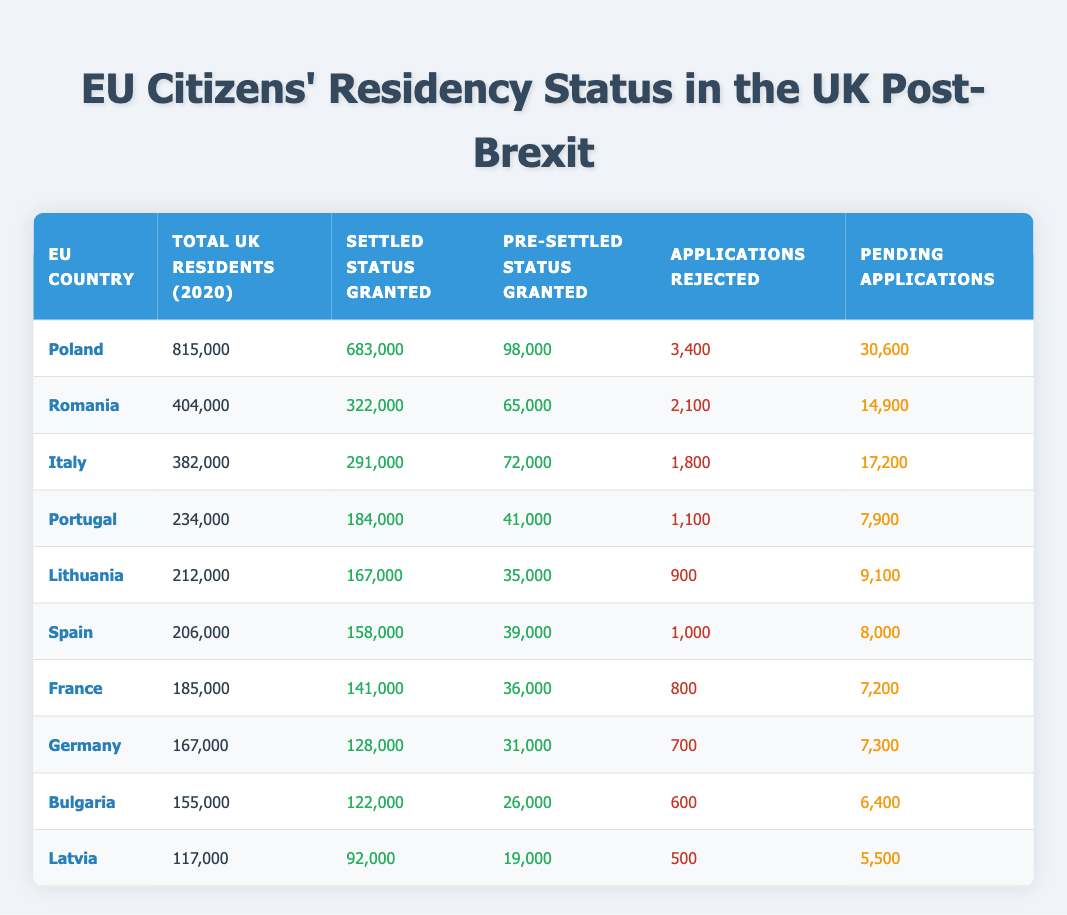What is the total number of applications rejected for EU citizens from Poland? The table shows that Poland had 3,400 applications rejected. It's taken directly from the "Applications Rejected" column for Poland.
Answer: 3,400 How many total applications (both granted statuses and applications rejected) were there for Romanian citizens? Combining the granted statuses (322,000 + 65,000) and rejected applications (2,100), the total applications can be calculated as 322,000 + 65,000 + 2,100 = 389,100.
Answer: 389,100 Is the number of EU citizens in the UK from Italy greater than that from Spain? The total UK residents from Italy are 382,000, while from Spain, it's 206,000. Since 382,000 is more than 206,000, the statement is true.
Answer: Yes What is the total number of settled and pre-settled statuses granted to EU citizens from Lithuania and Latvia combined? For Lithuania, the granted statuses total 167,000 (settled) + 35,000 (pre-settled) = 202,000. For Latvia, they total 92,000 (settled) + 19,000 (pre-settled) = 111,000. Adding both totals gives 202,000 + 111,000 = 313,000.
Answer: 313,000 Which EU country had the highest number of pending applications? Upon reviewing the table, Poland has the highest number of pending applications recorded at 30,600. This is taken from the "Pending Applications" column.
Answer: Poland What percentage of the total UK residents from Portugal have been granted settled status? The total UK residents from Portugal are 234,000. The number granted settled status is 184,000. To find the percentage, divide 184,000 by 234,000 and multiply by 100. This gives approximately 78.6%.
Answer: 78.6% Which country had more applications rejected: Lithuania or Bulgaria? Lithuania had 900 applications rejected while Bulgaria had 600 rejected. Since 900 is greater than 600, Lithuania had more rejected applications.
Answer: Lithuania How many more settled statuses were granted to EU citizens from Germany compared to Latvia? Germany had 128,000 settled statuses granted, while Latvia had 92,000. The difference is 128,000 - 92,000 = 36,000.
Answer: 36,000 What is the average number of applications pending across the listed EU countries? To find the average, sum all pending applications: 30,600 + 14,900 + 17,200 + 7,900 + 9,100 + 8,000 + 7,200 + 7,300 + 6,400 + 5,500 = 125,700. There are 10 countries, so the average is 125,700 / 10 = 12,570.
Answer: 12,570 